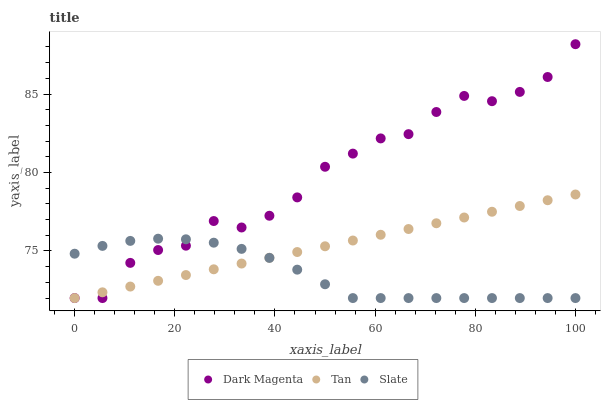Does Slate have the minimum area under the curve?
Answer yes or no. Yes. Does Dark Magenta have the maximum area under the curve?
Answer yes or no. Yes. Does Dark Magenta have the minimum area under the curve?
Answer yes or no. No. Does Slate have the maximum area under the curve?
Answer yes or no. No. Is Tan the smoothest?
Answer yes or no. Yes. Is Dark Magenta the roughest?
Answer yes or no. Yes. Is Slate the smoothest?
Answer yes or no. No. Is Slate the roughest?
Answer yes or no. No. Does Tan have the lowest value?
Answer yes or no. Yes. Does Dark Magenta have the highest value?
Answer yes or no. Yes. Does Slate have the highest value?
Answer yes or no. No. Does Tan intersect Dark Magenta?
Answer yes or no. Yes. Is Tan less than Dark Magenta?
Answer yes or no. No. Is Tan greater than Dark Magenta?
Answer yes or no. No. 